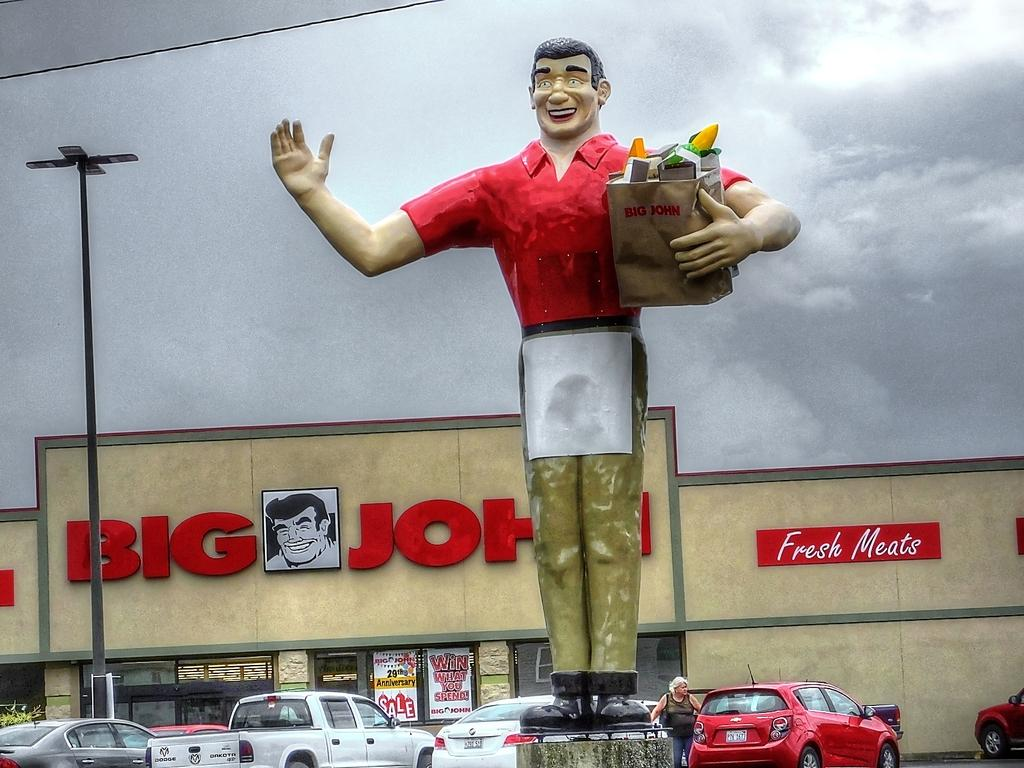What is the main object in the image? There is a statue in the image. What other structures or objects can be seen in the image? There is a light pole, vehicles, a house, a wire, posters, and a board with text in the image. What is the condition of the sky in the image? The sky is visible in the image. What type of thunder can be heard in the image? There is no sound present in the image, so it is not possible to determine if any thunder can be heard. --- Facts: 1. There is a person holding a book in the image. 2. The person is sitting on a chair. 3. There is a table in the image. 4. The table has a lamp on it. 5. There is a window in the image. 6. The window has curtains. Absurd Topics: dance, ocean, parrot Conversation: What is the person in the image doing? The person is holding a book in the image. What is the person's position in the image? The person is sitting on a chair. What is on the table in the image? There is a lamp on the table in the image. What can be seen through the window in the image? The window has curtains. Reasoning: Let's think step by step in order to produce the conversation. We start by identifying the main subject of the image, which is the person holding a book. Then, we describe the person's position and the objects around them, such as the chair, table, and lamp. Finally, we mention the window and its curtains, which are visible in the image. Absurd Question/Answer: Can you see any parrots flying outside the window in the image? There are no parrots visible in the image, and it is not possible to determine if any are flying outside the window. 